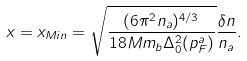<formula> <loc_0><loc_0><loc_500><loc_500>x = x _ { M i n } & = \sqrt { \frac { ( 6 \pi ^ { 2 } n _ { a } ) ^ { 4 / 3 } } { 1 8 M m _ { b } \Delta _ { 0 } ^ { 2 } ( p _ { F } ^ { a } ) } } \frac { \delta n } { n _ { a } } .</formula> 